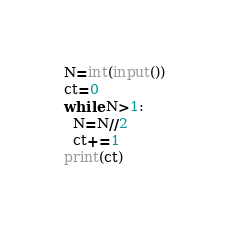Convert code to text. <code><loc_0><loc_0><loc_500><loc_500><_Python_>N=int(input())
ct=0
while N>1:
  N=N//2
  ct+=1
print(ct)</code> 